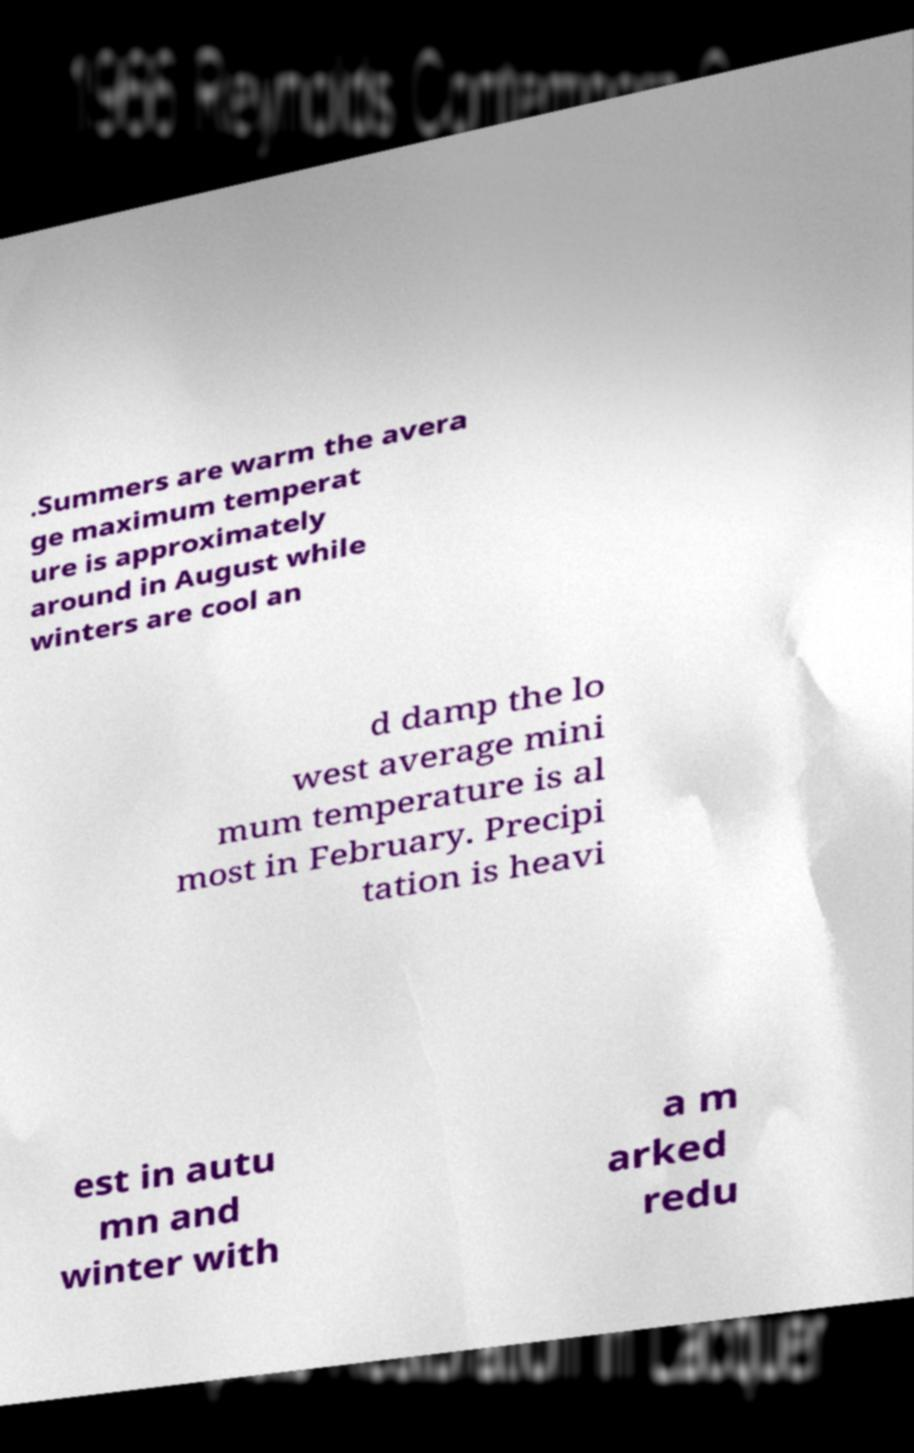Can you accurately transcribe the text from the provided image for me? .Summers are warm the avera ge maximum temperat ure is approximately around in August while winters are cool an d damp the lo west average mini mum temperature is al most in February. Precipi tation is heavi est in autu mn and winter with a m arked redu 